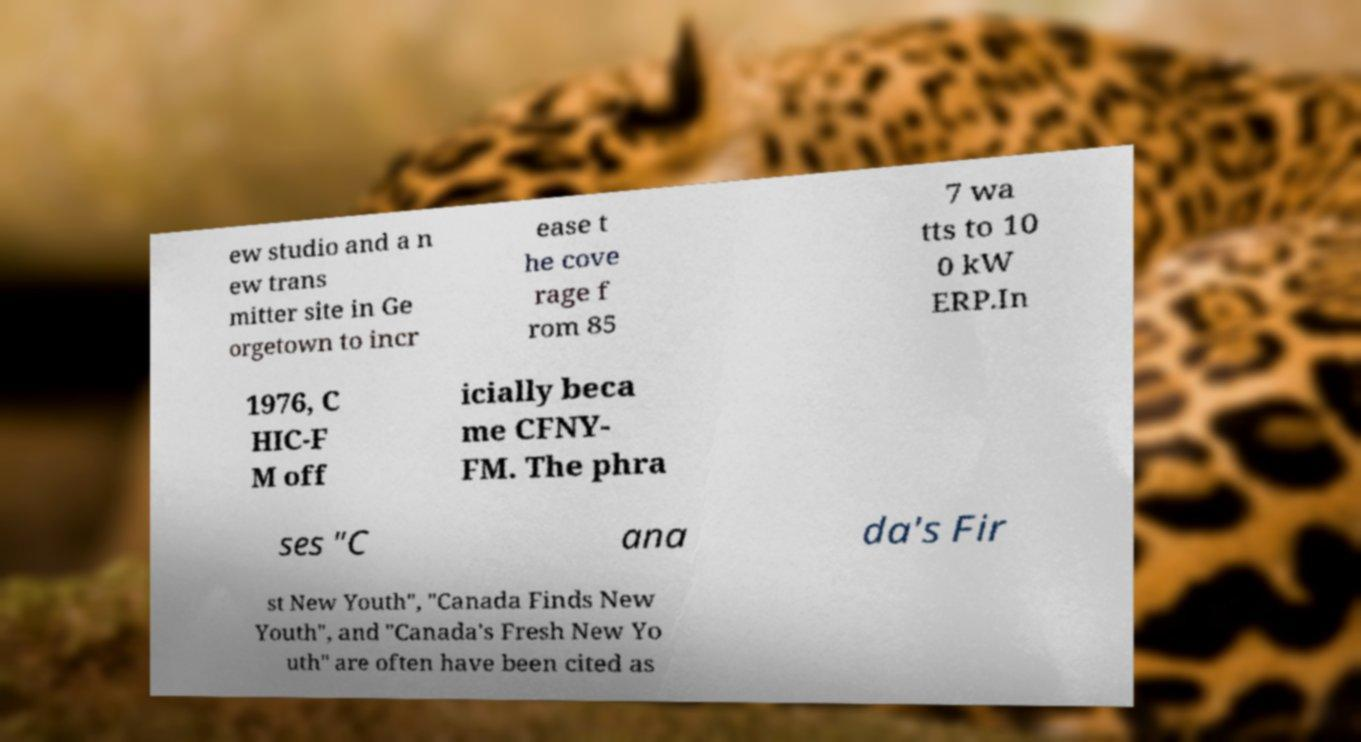I need the written content from this picture converted into text. Can you do that? ew studio and a n ew trans mitter site in Ge orgetown to incr ease t he cove rage f rom 85 7 wa tts to 10 0 kW ERP.In 1976, C HIC-F M off icially beca me CFNY- FM. The phra ses "C ana da's Fir st New Youth", "Canada Finds New Youth", and "Canada's Fresh New Yo uth" are often have been cited as 